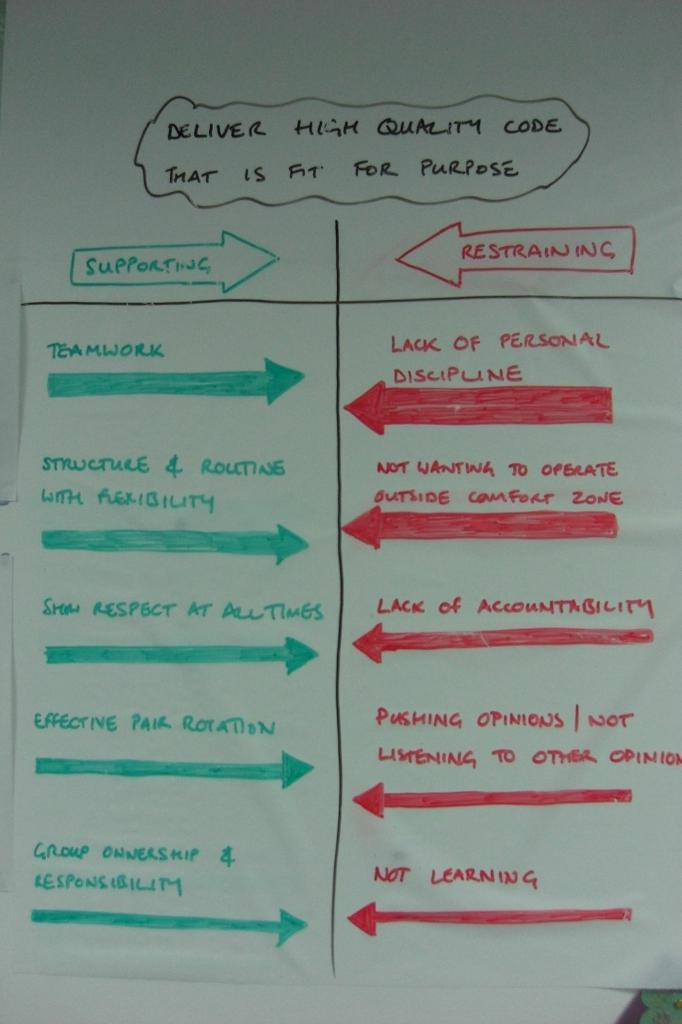<image>
Describe the image concisely. A list of supporting and restraining points for delivering high quality code. 